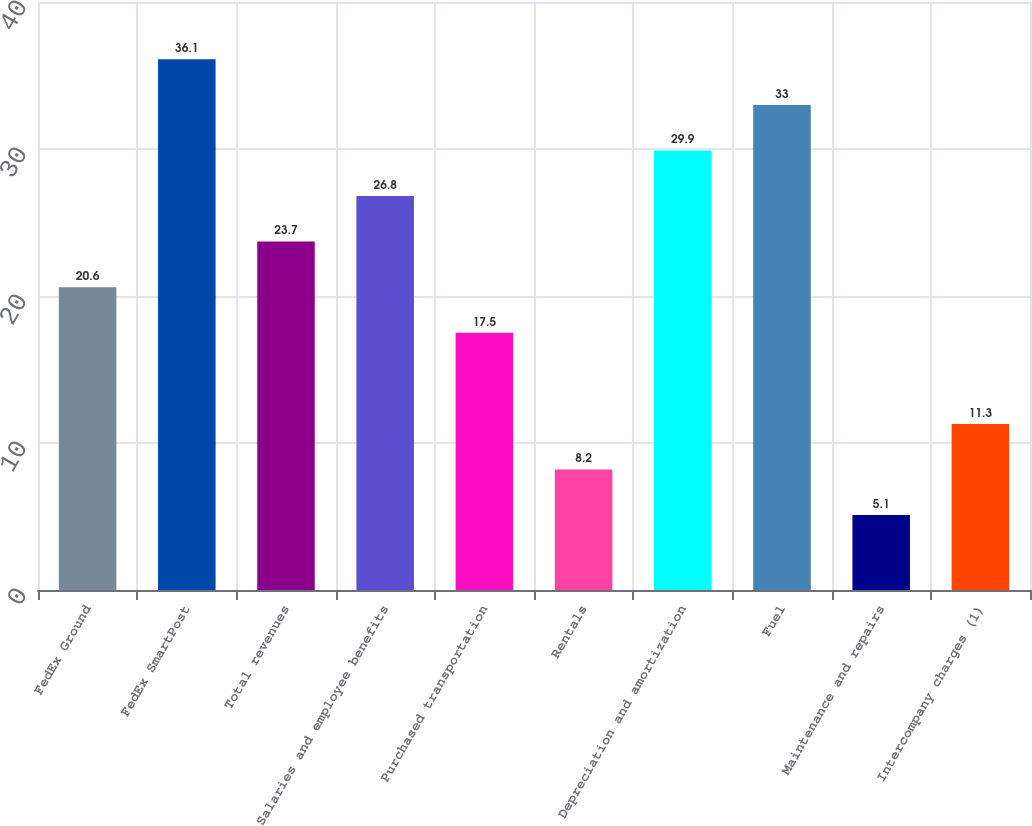Convert chart to OTSL. <chart><loc_0><loc_0><loc_500><loc_500><bar_chart><fcel>FedEx Ground<fcel>FedEx SmartPost<fcel>Total revenues<fcel>Salaries and employee benefits<fcel>Purchased transportation<fcel>Rentals<fcel>Depreciation and amortization<fcel>Fuel<fcel>Maintenance and repairs<fcel>Intercompany charges (1)<nl><fcel>20.6<fcel>36.1<fcel>23.7<fcel>26.8<fcel>17.5<fcel>8.2<fcel>29.9<fcel>33<fcel>5.1<fcel>11.3<nl></chart> 